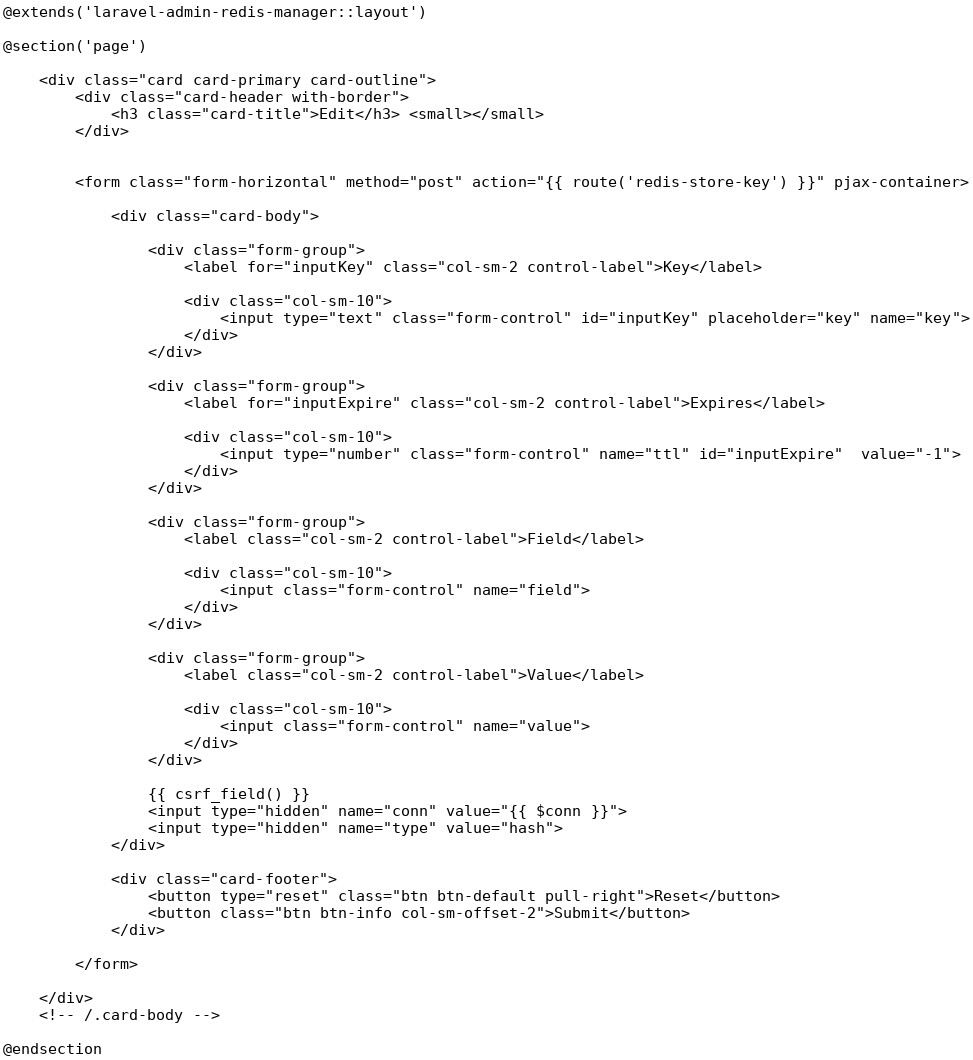<code> <loc_0><loc_0><loc_500><loc_500><_PHP_>@extends('laravel-admin-redis-manager::layout')

@section('page')

    <div class="card card-primary card-outline">
        <div class="card-header with-border">
            <h3 class="card-title">Edit</h3> <small></small>
        </div>


        <form class="form-horizontal" method="post" action="{{ route('redis-store-key') }}" pjax-container>

            <div class="card-body">

                <div class="form-group">
                    <label for="inputKey" class="col-sm-2 control-label">Key</label>

                    <div class="col-sm-10">
                        <input type="text" class="form-control" id="inputKey" placeholder="key" name="key">
                    </div>
                </div>

                <div class="form-group">
                    <label for="inputExpire" class="col-sm-2 control-label">Expires</label>

                    <div class="col-sm-10">
                        <input type="number" class="form-control" name="ttl" id="inputExpire"  value="-1">
                    </div>
                </div>

                <div class="form-group">
                    <label class="col-sm-2 control-label">Field</label>

                    <div class="col-sm-10">
                        <input class="form-control" name="field">
                    </div>
                </div>

                <div class="form-group">
                    <label class="col-sm-2 control-label">Value</label>

                    <div class="col-sm-10">
                        <input class="form-control" name="value">
                    </div>
                </div>

                {{ csrf_field() }}
                <input type="hidden" name="conn" value="{{ $conn }}">
                <input type="hidden" name="type" value="hash">
            </div>

            <div class="card-footer">
                <button type="reset" class="btn btn-default pull-right">Reset</button>
                <button class="btn btn-info col-sm-offset-2">Submit</button>
            </div>

        </form>

    </div>
    <!-- /.card-body -->

@endsection</code> 